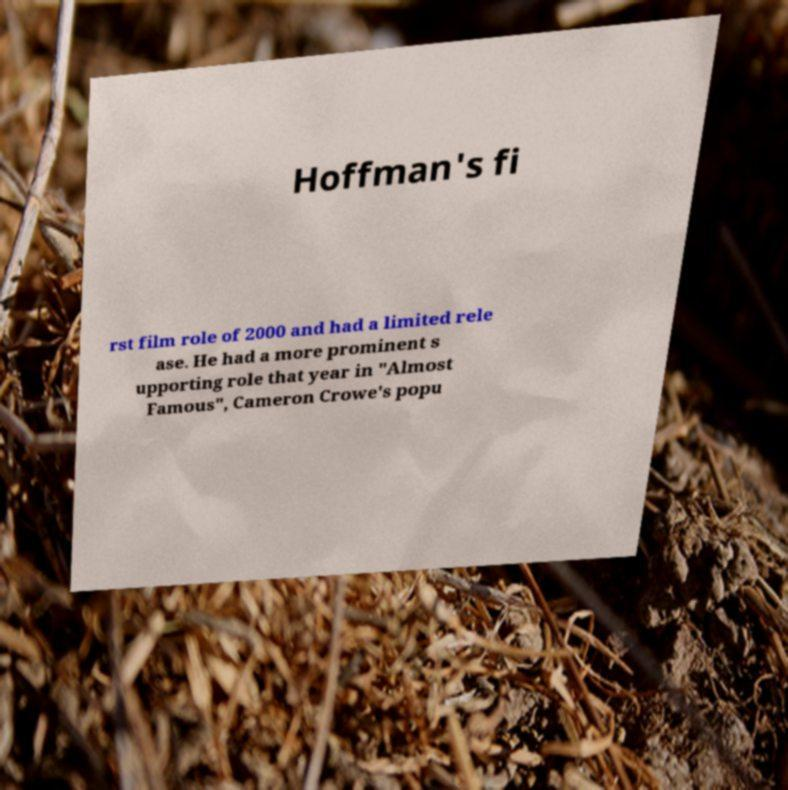I need the written content from this picture converted into text. Can you do that? Hoffman's fi rst film role of 2000 and had a limited rele ase. He had a more prominent s upporting role that year in "Almost Famous", Cameron Crowe's popu 